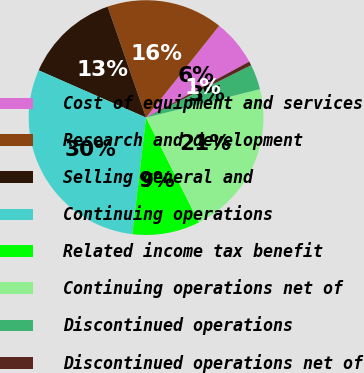Convert chart to OTSL. <chart><loc_0><loc_0><loc_500><loc_500><pie_chart><fcel>Cost of equipment and services<fcel>Research and development<fcel>Selling general and<fcel>Continuing operations<fcel>Related income tax benefit<fcel>Continuing operations net of<fcel>Discontinued operations<fcel>Discontinued operations net of<nl><fcel>6.38%<fcel>16.01%<fcel>13.1%<fcel>29.73%<fcel>9.3%<fcel>21.46%<fcel>3.47%<fcel>0.55%<nl></chart> 